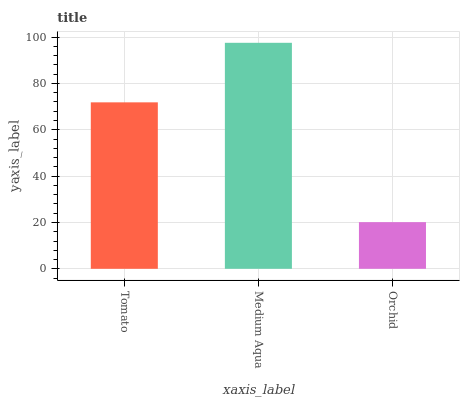Is Orchid the minimum?
Answer yes or no. Yes. Is Medium Aqua the maximum?
Answer yes or no. Yes. Is Medium Aqua the minimum?
Answer yes or no. No. Is Orchid the maximum?
Answer yes or no. No. Is Medium Aqua greater than Orchid?
Answer yes or no. Yes. Is Orchid less than Medium Aqua?
Answer yes or no. Yes. Is Orchid greater than Medium Aqua?
Answer yes or no. No. Is Medium Aqua less than Orchid?
Answer yes or no. No. Is Tomato the high median?
Answer yes or no. Yes. Is Tomato the low median?
Answer yes or no. Yes. Is Orchid the high median?
Answer yes or no. No. Is Medium Aqua the low median?
Answer yes or no. No. 